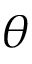Convert formula to latex. <formula><loc_0><loc_0><loc_500><loc_500>\theta</formula> 